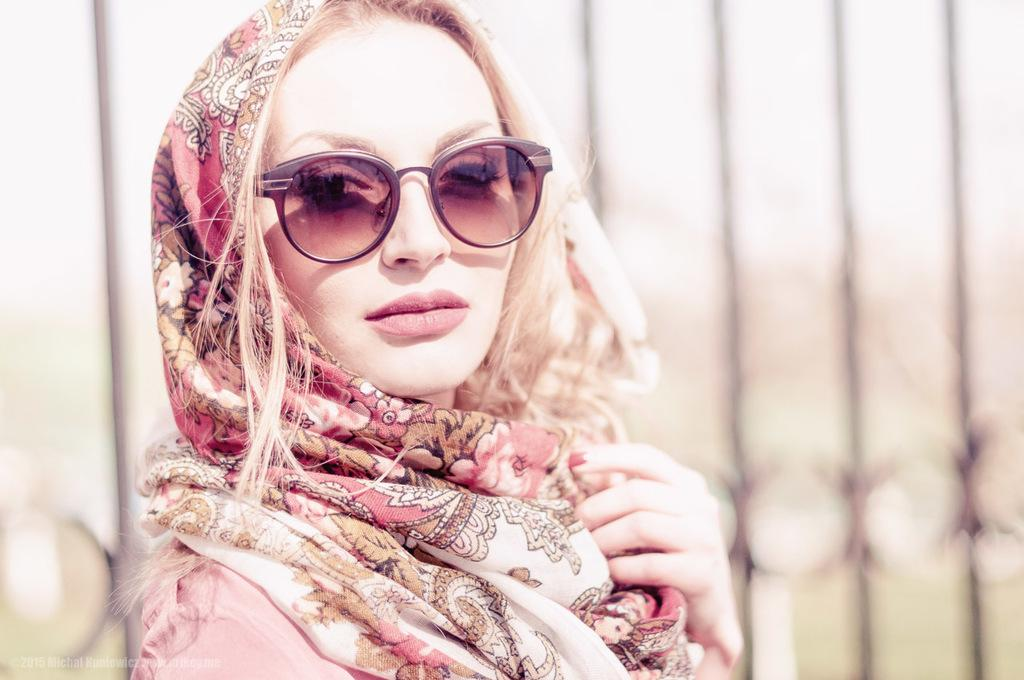Who is the main subject in the image? There is a woman in the center of the image. What is the woman wearing in the image? The woman is wearing spectacles in the image. What can be seen in the background of the image? There is fencing visible in the background of the image. What type of box can be seen in the image? There is no box present in the image. What sense is the woman using to read a book in the image? The image does not show the woman reading a book, so it is not possible to determine which sense she might be using. 